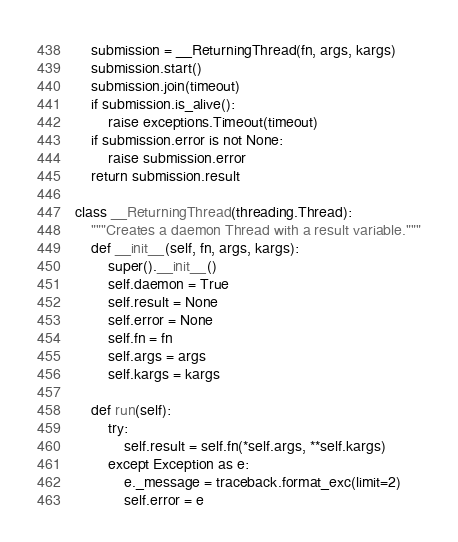Convert code to text. <code><loc_0><loc_0><loc_500><loc_500><_Python_>
    submission = __ReturningThread(fn, args, kargs)
    submission.start()
    submission.join(timeout)
    if submission.is_alive():
        raise exceptions.Timeout(timeout)
    if submission.error is not None:
        raise submission.error
    return submission.result

class __ReturningThread(threading.Thread):
    """Creates a daemon Thread with a result variable."""
    def __init__(self, fn, args, kargs):
        super().__init__()
        self.daemon = True
        self.result = None
        self.error = None
        self.fn = fn
        self.args = args
        self.kargs = kargs

    def run(self):
        try:
            self.result = self.fn(*self.args, **self.kargs)
        except Exception as e:
            e._message = traceback.format_exc(limit=2)
            self.error = e

</code> 